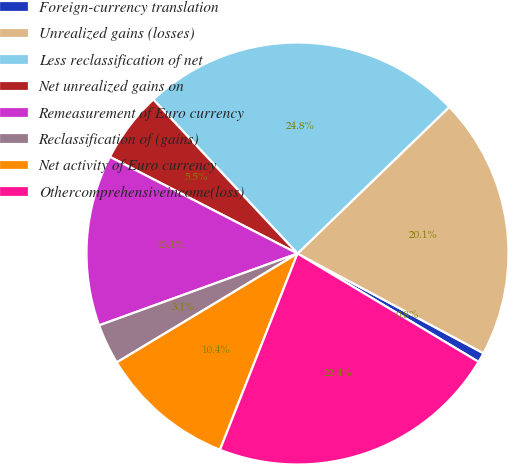<chart> <loc_0><loc_0><loc_500><loc_500><pie_chart><fcel>Foreign-currency translation<fcel>Unrealized gains (losses)<fcel>Less reclassification of net<fcel>Net unrealized gains on<fcel>Remeasurement of Euro currency<fcel>Reclassification of (gains)<fcel>Net activity of Euro currency<fcel>Othercomprehensiveincome(loss)<nl><fcel>0.75%<fcel>20.05%<fcel>24.75%<fcel>5.45%<fcel>13.1%<fcel>3.1%<fcel>10.38%<fcel>22.4%<nl></chart> 